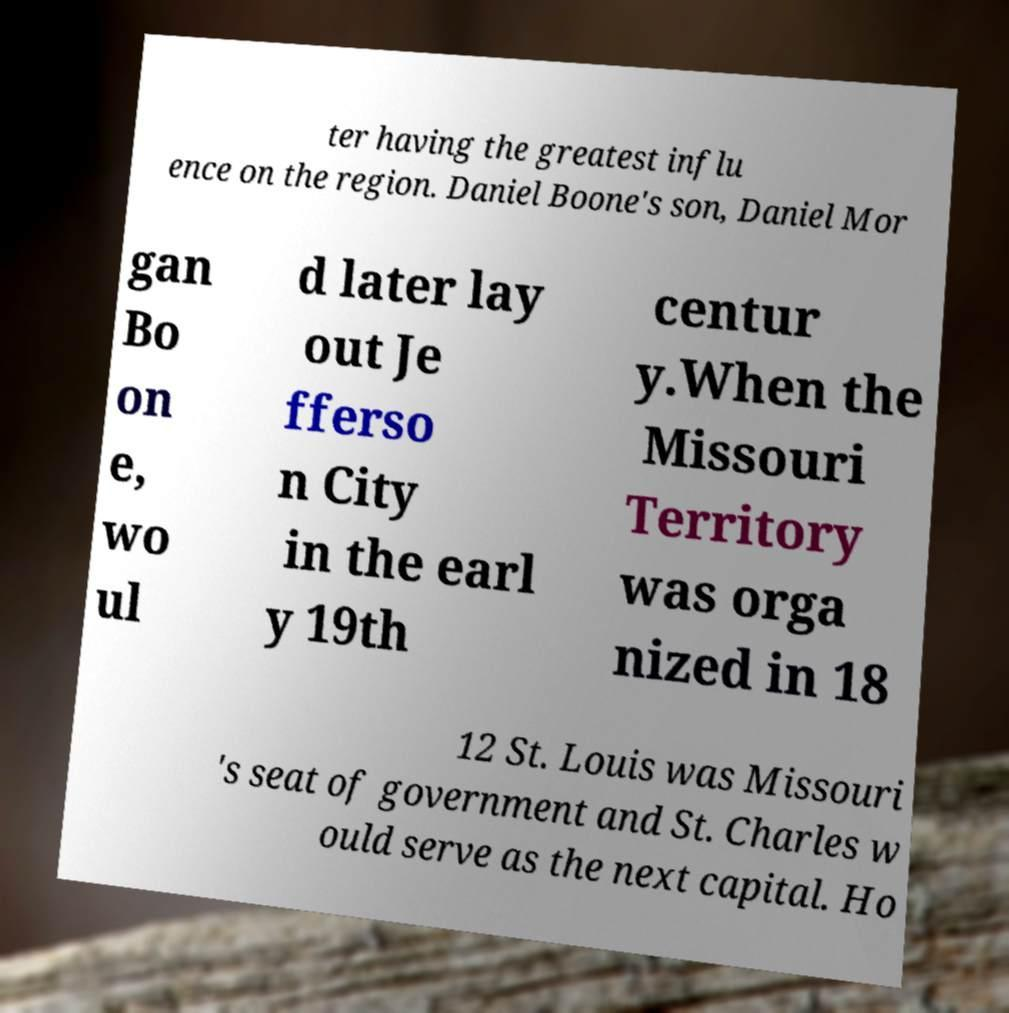There's text embedded in this image that I need extracted. Can you transcribe it verbatim? ter having the greatest influ ence on the region. Daniel Boone's son, Daniel Mor gan Bo on e, wo ul d later lay out Je fferso n City in the earl y 19th centur y.When the Missouri Territory was orga nized in 18 12 St. Louis was Missouri 's seat of government and St. Charles w ould serve as the next capital. Ho 